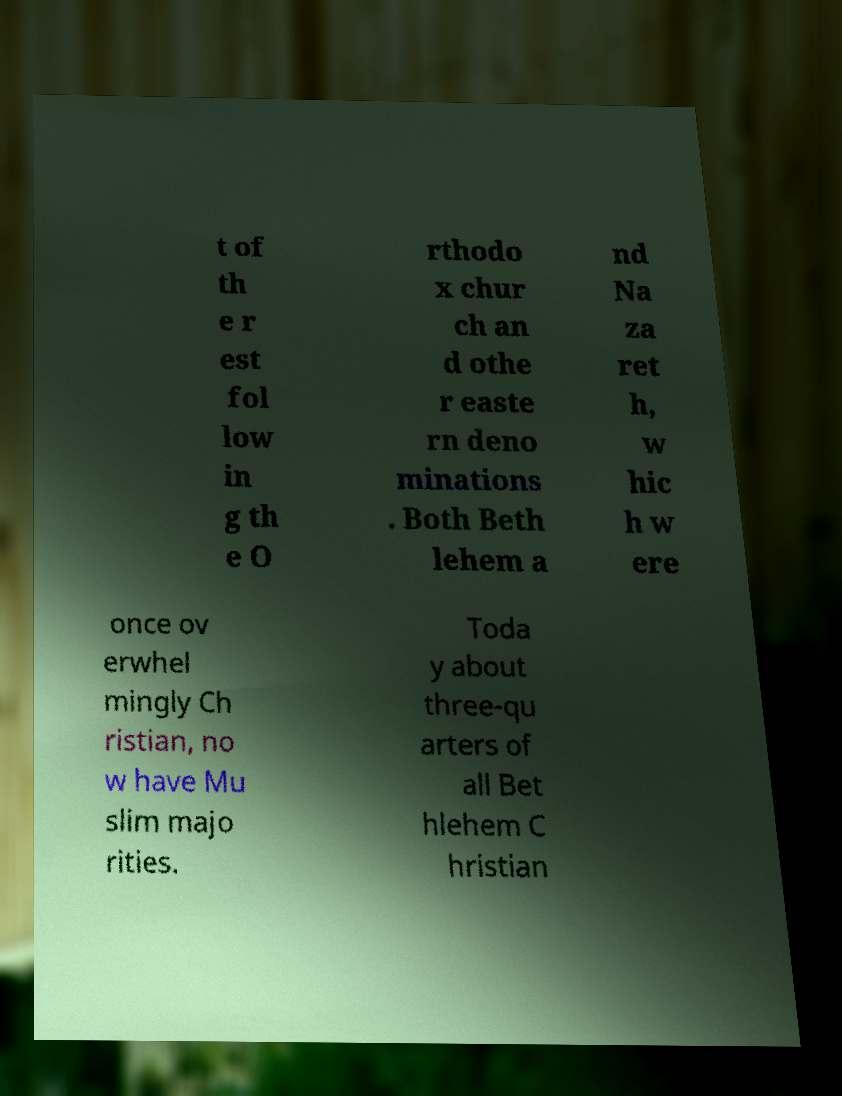Please identify and transcribe the text found in this image. t of th e r est fol low in g th e O rthodo x chur ch an d othe r easte rn deno minations . Both Beth lehem a nd Na za ret h, w hic h w ere once ov erwhel mingly Ch ristian, no w have Mu slim majo rities. Toda y about three-qu arters of all Bet hlehem C hristian 